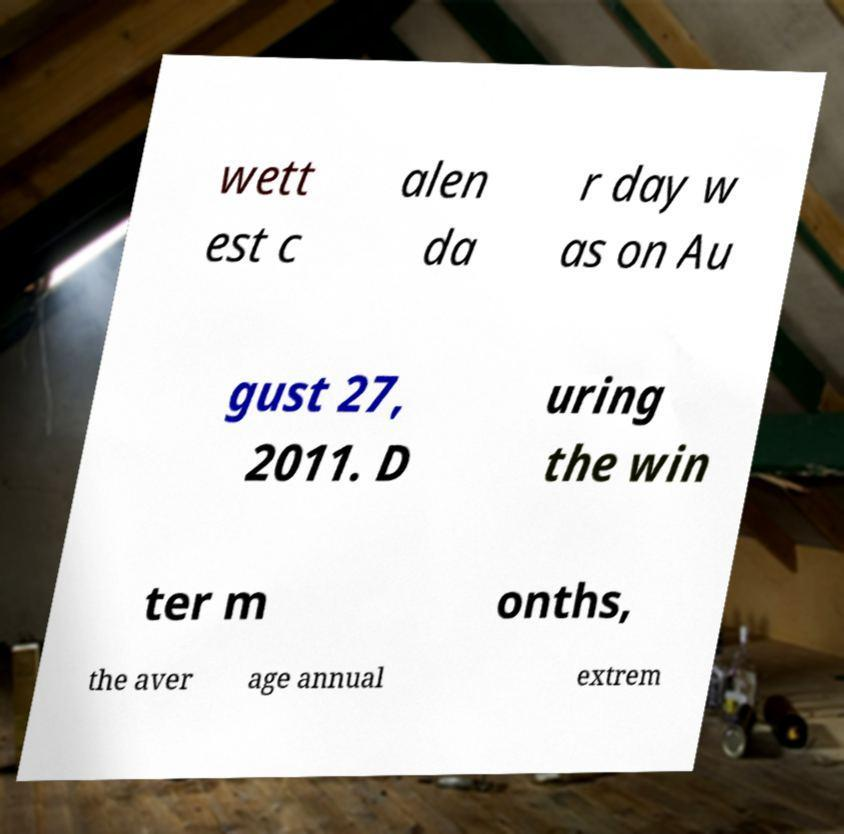There's text embedded in this image that I need extracted. Can you transcribe it verbatim? wett est c alen da r day w as on Au gust 27, 2011. D uring the win ter m onths, the aver age annual extrem 